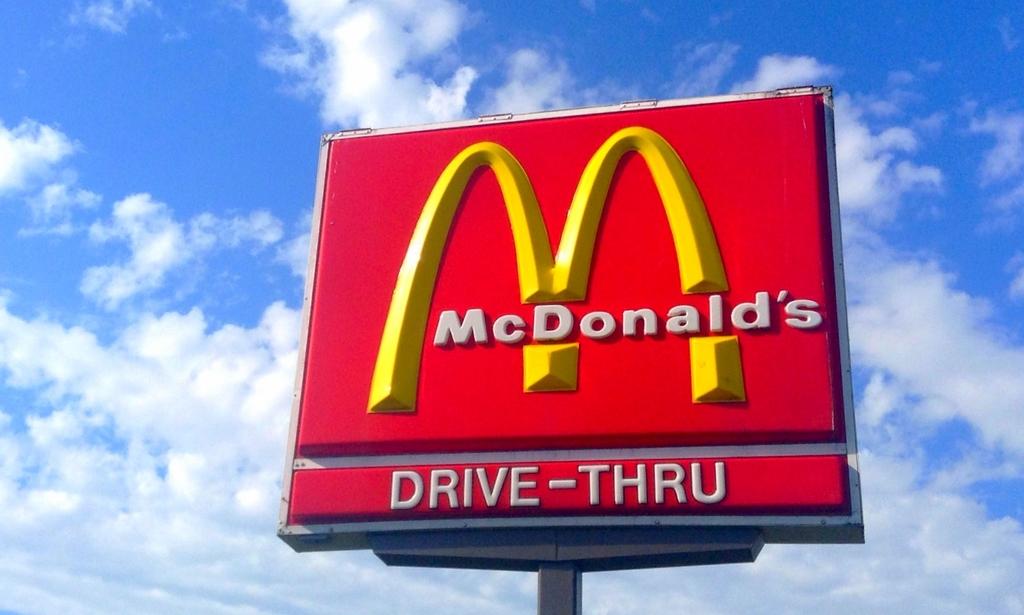What restaurant is this?
Your response must be concise. Mcdonald's. 